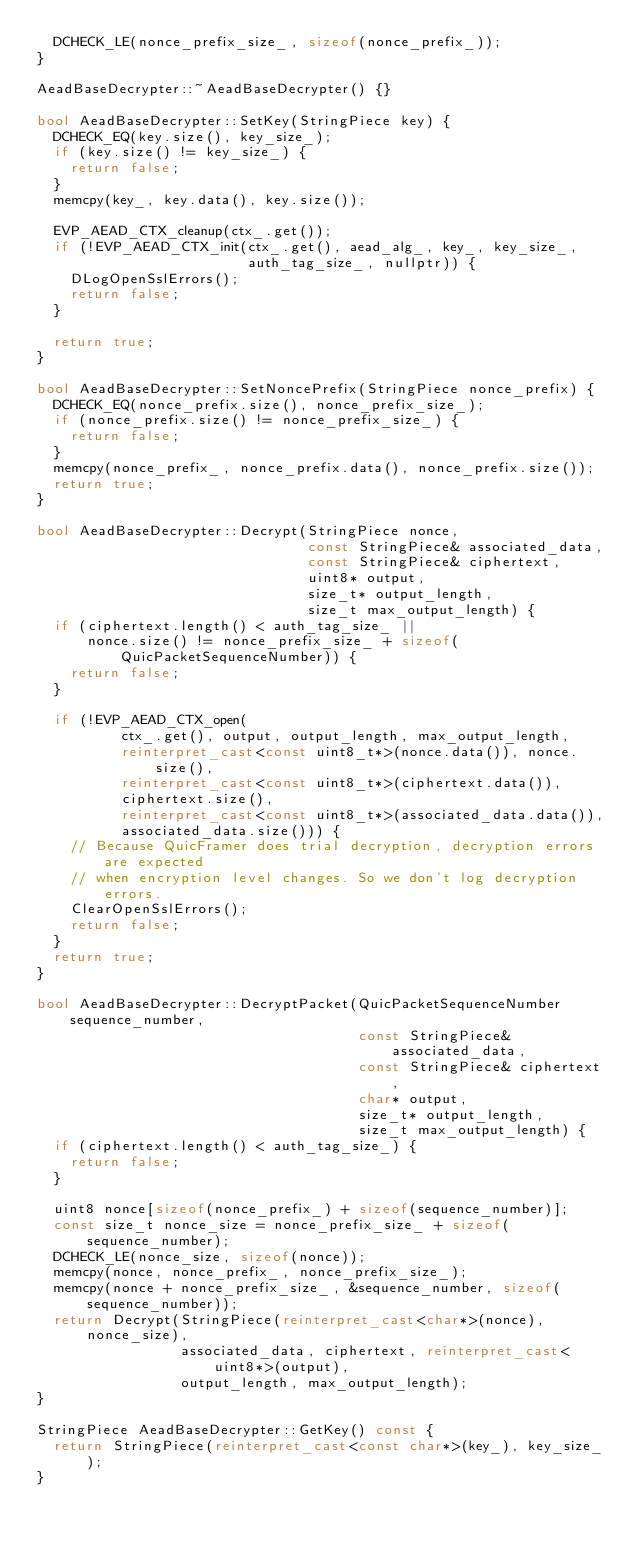Convert code to text. <code><loc_0><loc_0><loc_500><loc_500><_C++_>  DCHECK_LE(nonce_prefix_size_, sizeof(nonce_prefix_));
}

AeadBaseDecrypter::~AeadBaseDecrypter() {}

bool AeadBaseDecrypter::SetKey(StringPiece key) {
  DCHECK_EQ(key.size(), key_size_);
  if (key.size() != key_size_) {
    return false;
  }
  memcpy(key_, key.data(), key.size());

  EVP_AEAD_CTX_cleanup(ctx_.get());
  if (!EVP_AEAD_CTX_init(ctx_.get(), aead_alg_, key_, key_size_,
                         auth_tag_size_, nullptr)) {
    DLogOpenSslErrors();
    return false;
  }

  return true;
}

bool AeadBaseDecrypter::SetNoncePrefix(StringPiece nonce_prefix) {
  DCHECK_EQ(nonce_prefix.size(), nonce_prefix_size_);
  if (nonce_prefix.size() != nonce_prefix_size_) {
    return false;
  }
  memcpy(nonce_prefix_, nonce_prefix.data(), nonce_prefix.size());
  return true;
}

bool AeadBaseDecrypter::Decrypt(StringPiece nonce,
                                const StringPiece& associated_data,
                                const StringPiece& ciphertext,
                                uint8* output,
                                size_t* output_length,
                                size_t max_output_length) {
  if (ciphertext.length() < auth_tag_size_ ||
      nonce.size() != nonce_prefix_size_ + sizeof(QuicPacketSequenceNumber)) {
    return false;
  }

  if (!EVP_AEAD_CTX_open(
          ctx_.get(), output, output_length, max_output_length,
          reinterpret_cast<const uint8_t*>(nonce.data()), nonce.size(),
          reinterpret_cast<const uint8_t*>(ciphertext.data()),
          ciphertext.size(),
          reinterpret_cast<const uint8_t*>(associated_data.data()),
          associated_data.size())) {
    // Because QuicFramer does trial decryption, decryption errors are expected
    // when encryption level changes. So we don't log decryption errors.
    ClearOpenSslErrors();
    return false;
  }
  return true;
}

bool AeadBaseDecrypter::DecryptPacket(QuicPacketSequenceNumber sequence_number,
                                      const StringPiece& associated_data,
                                      const StringPiece& ciphertext,
                                      char* output,
                                      size_t* output_length,
                                      size_t max_output_length) {
  if (ciphertext.length() < auth_tag_size_) {
    return false;
  }

  uint8 nonce[sizeof(nonce_prefix_) + sizeof(sequence_number)];
  const size_t nonce_size = nonce_prefix_size_ + sizeof(sequence_number);
  DCHECK_LE(nonce_size, sizeof(nonce));
  memcpy(nonce, nonce_prefix_, nonce_prefix_size_);
  memcpy(nonce + nonce_prefix_size_, &sequence_number, sizeof(sequence_number));
  return Decrypt(StringPiece(reinterpret_cast<char*>(nonce), nonce_size),
                 associated_data, ciphertext, reinterpret_cast<uint8*>(output),
                 output_length, max_output_length);
}

StringPiece AeadBaseDecrypter::GetKey() const {
  return StringPiece(reinterpret_cast<const char*>(key_), key_size_);
}
</code> 